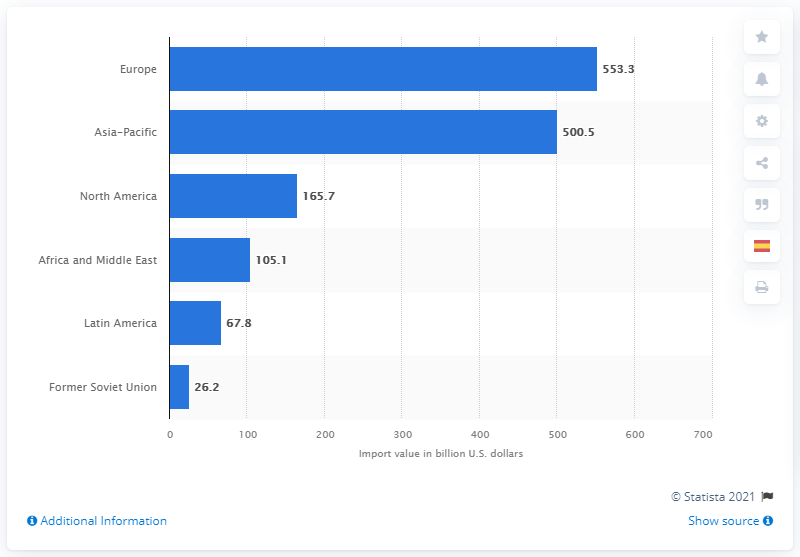List a handful of essential elements in this visual. In 2019, the value of Europe's chemical imports in dollars was 553.3. In 2019, the chemical import value of North America was 165.7 billion dollars. 